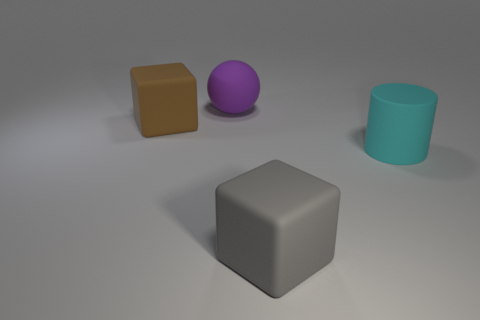Add 1 big balls. How many objects exist? 5 Subtract all gray blocks. How many blocks are left? 1 Subtract all cylinders. How many objects are left? 3 Subtract all red cylinders. How many brown blocks are left? 1 Subtract all large cyan cylinders. Subtract all purple things. How many objects are left? 2 Add 1 big objects. How many big objects are left? 5 Add 3 green things. How many green things exist? 3 Subtract 1 brown cubes. How many objects are left? 3 Subtract 1 spheres. How many spheres are left? 0 Subtract all blue cylinders. Subtract all purple spheres. How many cylinders are left? 1 